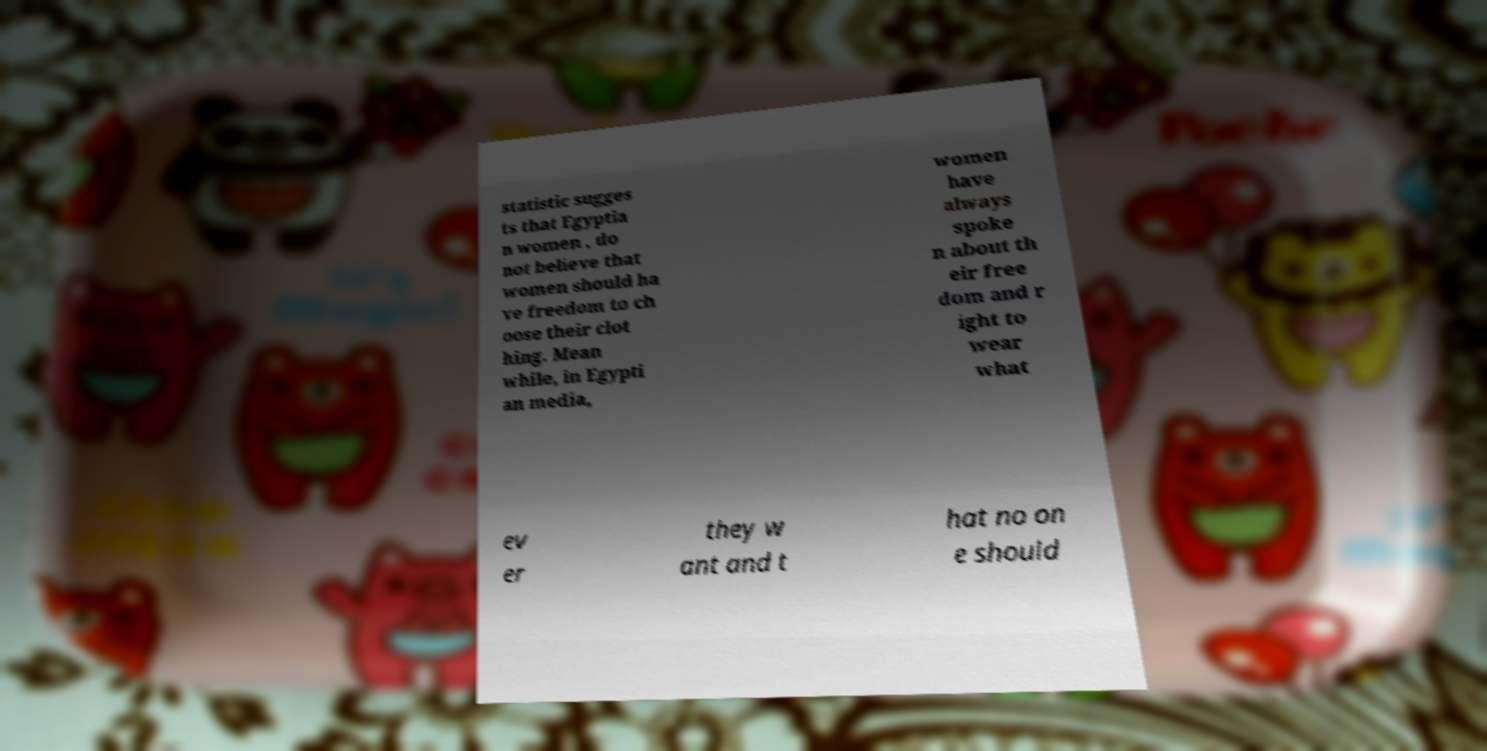Please identify and transcribe the text found in this image. statistic sugges ts that Egyptia n women , do not believe that women should ha ve freedom to ch oose their clot hing. Mean while, in Egypti an media, women have always spoke n about th eir free dom and r ight to wear what ev er they w ant and t hat no on e should 